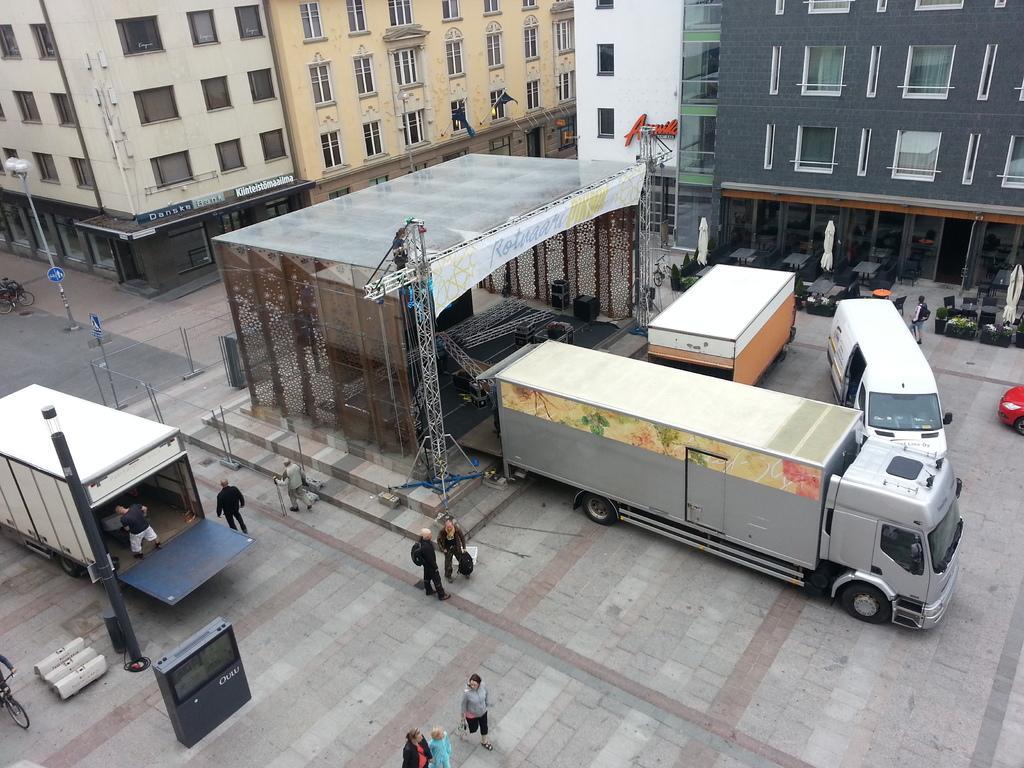In one or two sentences, can you explain what this image depicts? In this image in the front there are persons standing and walking. In the background there are vehicles and there are buildings and there are poles. On the left side there is a person riding a bicycle. 